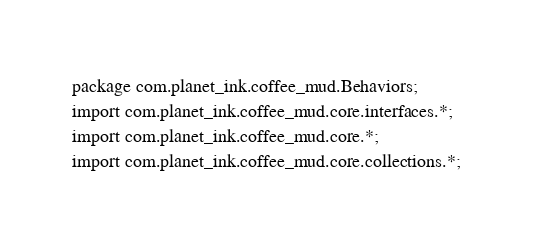<code> <loc_0><loc_0><loc_500><loc_500><_Java_>package com.planet_ink.coffee_mud.Behaviors;
import com.planet_ink.coffee_mud.core.interfaces.*;
import com.planet_ink.coffee_mud.core.*;
import com.planet_ink.coffee_mud.core.collections.*;</code> 